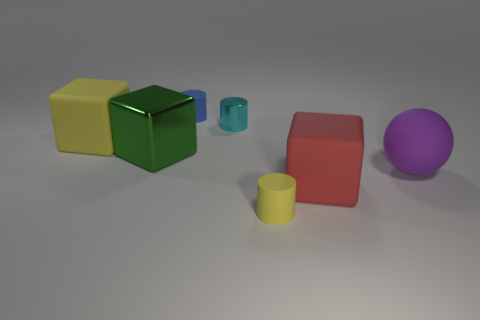Add 1 large green cubes. How many objects exist? 8 Subtract all cylinders. How many objects are left? 4 Add 6 tiny brown matte objects. How many tiny brown matte objects exist? 6 Subtract 0 gray balls. How many objects are left? 7 Subtract all cyan metallic cylinders. Subtract all metal cylinders. How many objects are left? 5 Add 6 big green things. How many big green things are left? 7 